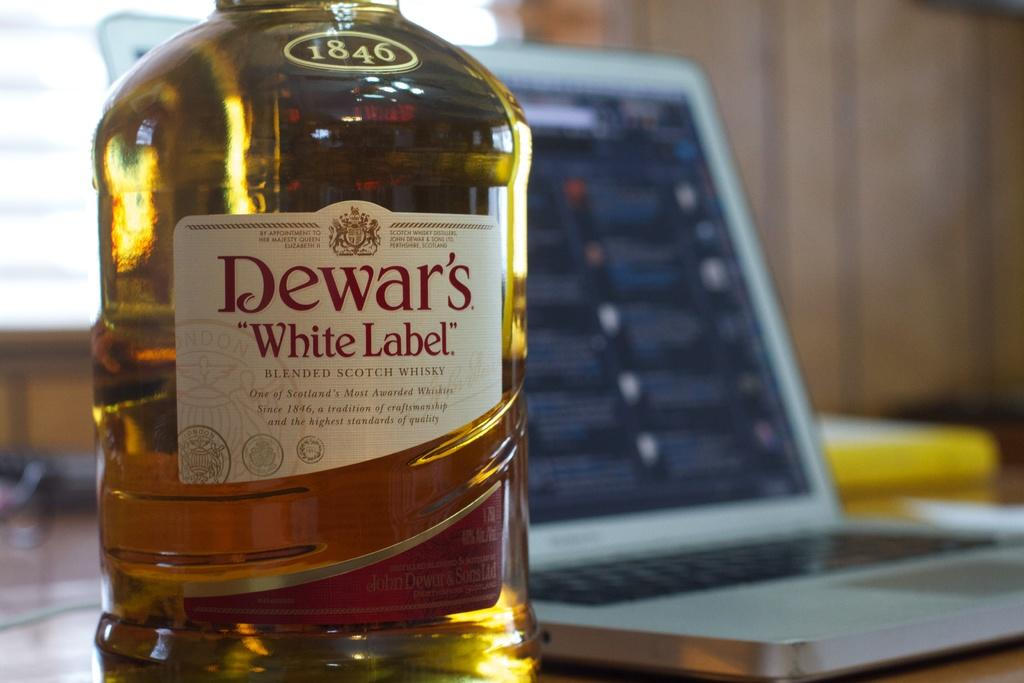Provide a one-sentence caption for the provided image. A bottle of Dewar's White Label blended scotch whiskey. 